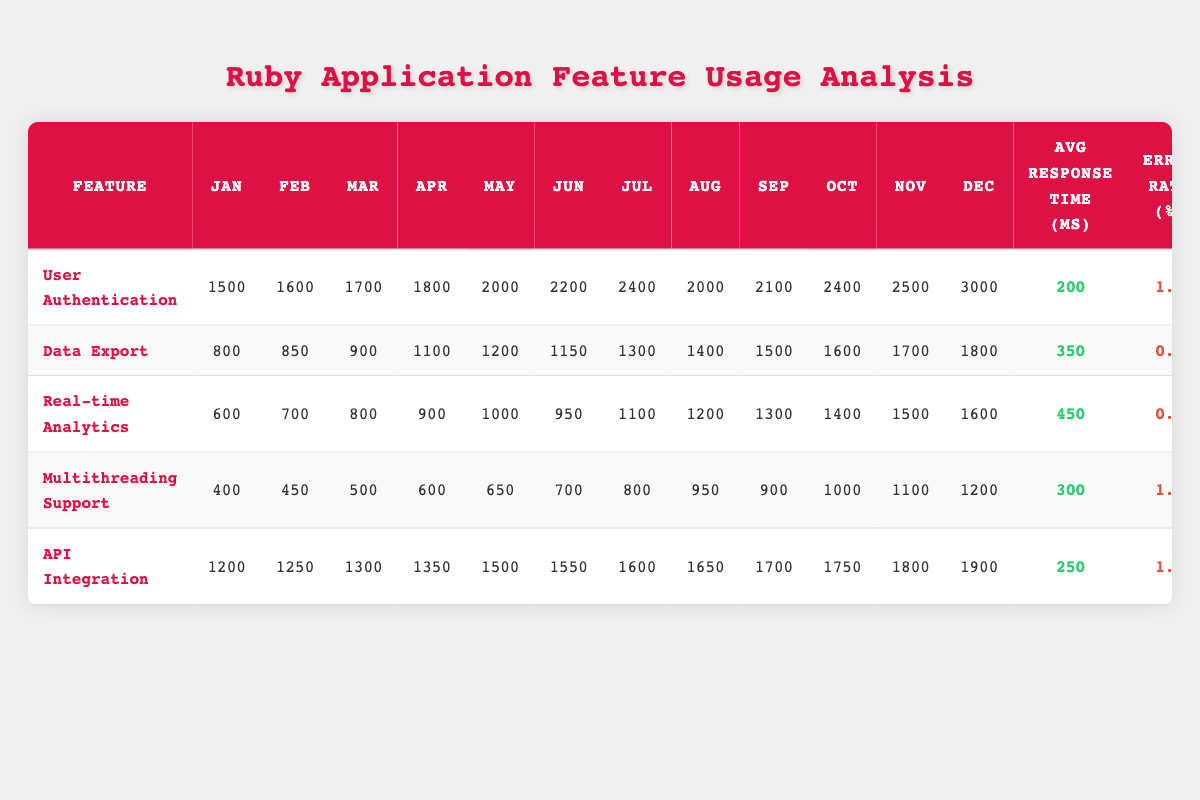What was the highest monthly usage for User Authentication? Looking at the monthly usage for User Authentication, the data shows a peak in December with 3000 usages.
Answer: 3000 In which month did the Data Export feature have the lowest usage? By reviewing the monthly usage data for Data Export, January shows the lowest usage at 800.
Answer: January What is the average response time for Real-time Analytics? The table lists the average response time for Real-time Analytics as 450 ms.
Answer: 450 ms What was the total usage for Multithreading Support over the entire year? Adding up the usage from each month for Multithreading Support: 400 + 450 + 500 + 600 + 650 + 700 + 800 + 950 + 900 + 1000 + 1100 + 1200 equals 10,000.
Answer: 10,000 Is the error rate for API Integration higher than that of Data Export? The error rate for API Integration is 1.5%, and for Data Export, it is 0.8%. Since 1.5% is greater, the statement is true.
Answer: Yes Which feature had the most significant increase in usage from January to December? User Authentication went from 1500 in January to 3000 in December, an increase of 1500, which is greater than the increases seen in other features.
Answer: User Authentication Calculate the average error rate across all features. The error rates are: 1.2, 0.8, 0.5, 1.0, and 1.5. The sum is (1.2 + 0.8 + 0.5 + 1.0 + 1.5) = 5.0. Dividing by 5 gives an average of 1.0.
Answer: 1.0 What is the difference in average usage between User Authentication and Real-time Analytics? The average usage for User Authentication is 2000 (calculated from the monthly data average) and 1150 for Real-time Analytics. The difference is 2000 - 1150 = 850.
Answer: 850 In what month did Multithreading Support reach its peak usage? Looking at Multiprocessing Support's monthly data, the highest usage occurred in December with 1200.
Answer: December Did the usage for Real-time Analytics consistently increase every month? The monthly usage does not show consistent increases, as it decreased from August (1200) to September (1300), so the answer is no.
Answer: No 